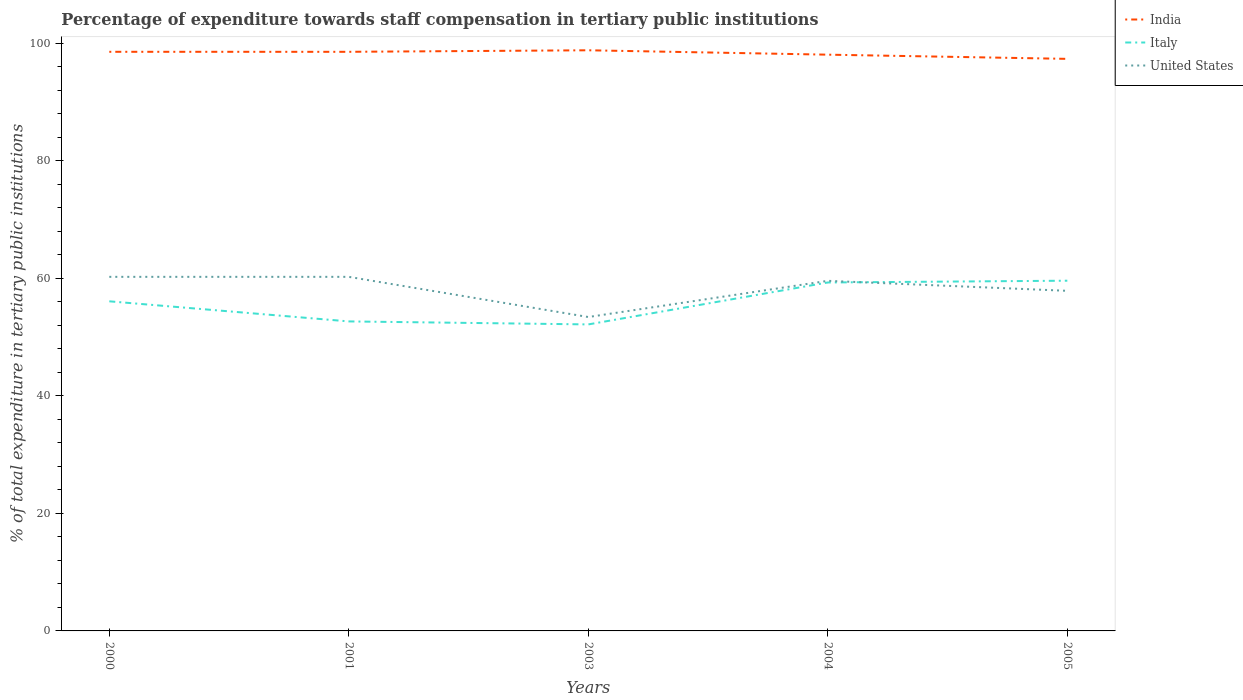How many different coloured lines are there?
Ensure brevity in your answer.  3. Across all years, what is the maximum percentage of expenditure towards staff compensation in Italy?
Keep it short and to the point. 52.15. In which year was the percentage of expenditure towards staff compensation in United States maximum?
Your answer should be very brief. 2003. What is the total percentage of expenditure towards staff compensation in India in the graph?
Ensure brevity in your answer.  1.2. What is the difference between the highest and the second highest percentage of expenditure towards staff compensation in United States?
Ensure brevity in your answer.  6.84. What is the difference between the highest and the lowest percentage of expenditure towards staff compensation in Italy?
Your response must be concise. 3. Is the percentage of expenditure towards staff compensation in United States strictly greater than the percentage of expenditure towards staff compensation in India over the years?
Your answer should be very brief. Yes. How many years are there in the graph?
Provide a succinct answer. 5. What is the difference between two consecutive major ticks on the Y-axis?
Your response must be concise. 20. Are the values on the major ticks of Y-axis written in scientific E-notation?
Offer a terse response. No. Where does the legend appear in the graph?
Make the answer very short. Top right. How many legend labels are there?
Offer a very short reply. 3. What is the title of the graph?
Provide a succinct answer. Percentage of expenditure towards staff compensation in tertiary public institutions. What is the label or title of the X-axis?
Provide a short and direct response. Years. What is the label or title of the Y-axis?
Provide a succinct answer. % of total expenditure in tertiary public institutions. What is the % of total expenditure in tertiary public institutions of India in 2000?
Give a very brief answer. 98.53. What is the % of total expenditure in tertiary public institutions in Italy in 2000?
Your response must be concise. 56.08. What is the % of total expenditure in tertiary public institutions of United States in 2000?
Make the answer very short. 60.24. What is the % of total expenditure in tertiary public institutions in India in 2001?
Make the answer very short. 98.53. What is the % of total expenditure in tertiary public institutions of Italy in 2001?
Provide a short and direct response. 52.66. What is the % of total expenditure in tertiary public institutions of United States in 2001?
Offer a very short reply. 60.24. What is the % of total expenditure in tertiary public institutions in India in 2003?
Provide a succinct answer. 98.79. What is the % of total expenditure in tertiary public institutions of Italy in 2003?
Your response must be concise. 52.15. What is the % of total expenditure in tertiary public institutions of United States in 2003?
Your response must be concise. 53.41. What is the % of total expenditure in tertiary public institutions of India in 2004?
Offer a terse response. 98.04. What is the % of total expenditure in tertiary public institutions of Italy in 2004?
Make the answer very short. 59.28. What is the % of total expenditure in tertiary public institutions in United States in 2004?
Give a very brief answer. 59.56. What is the % of total expenditure in tertiary public institutions in India in 2005?
Make the answer very short. 97.33. What is the % of total expenditure in tertiary public institutions of Italy in 2005?
Offer a terse response. 59.59. What is the % of total expenditure in tertiary public institutions of United States in 2005?
Give a very brief answer. 57.86. Across all years, what is the maximum % of total expenditure in tertiary public institutions in India?
Your response must be concise. 98.79. Across all years, what is the maximum % of total expenditure in tertiary public institutions of Italy?
Provide a short and direct response. 59.59. Across all years, what is the maximum % of total expenditure in tertiary public institutions in United States?
Provide a succinct answer. 60.24. Across all years, what is the minimum % of total expenditure in tertiary public institutions of India?
Your response must be concise. 97.33. Across all years, what is the minimum % of total expenditure in tertiary public institutions in Italy?
Offer a very short reply. 52.15. Across all years, what is the minimum % of total expenditure in tertiary public institutions in United States?
Make the answer very short. 53.41. What is the total % of total expenditure in tertiary public institutions in India in the graph?
Offer a terse response. 491.22. What is the total % of total expenditure in tertiary public institutions in Italy in the graph?
Provide a succinct answer. 279.76. What is the total % of total expenditure in tertiary public institutions of United States in the graph?
Your response must be concise. 291.32. What is the difference between the % of total expenditure in tertiary public institutions in India in 2000 and that in 2001?
Offer a very short reply. 0. What is the difference between the % of total expenditure in tertiary public institutions of Italy in 2000 and that in 2001?
Your answer should be compact. 3.42. What is the difference between the % of total expenditure in tertiary public institutions in United States in 2000 and that in 2001?
Provide a short and direct response. 0. What is the difference between the % of total expenditure in tertiary public institutions of India in 2000 and that in 2003?
Provide a short and direct response. -0.26. What is the difference between the % of total expenditure in tertiary public institutions of Italy in 2000 and that in 2003?
Ensure brevity in your answer.  3.93. What is the difference between the % of total expenditure in tertiary public institutions of United States in 2000 and that in 2003?
Make the answer very short. 6.84. What is the difference between the % of total expenditure in tertiary public institutions in India in 2000 and that in 2004?
Provide a succinct answer. 0.49. What is the difference between the % of total expenditure in tertiary public institutions of Italy in 2000 and that in 2004?
Your answer should be compact. -3.2. What is the difference between the % of total expenditure in tertiary public institutions in United States in 2000 and that in 2004?
Offer a terse response. 0.68. What is the difference between the % of total expenditure in tertiary public institutions in India in 2000 and that in 2005?
Your response must be concise. 1.2. What is the difference between the % of total expenditure in tertiary public institutions of Italy in 2000 and that in 2005?
Provide a succinct answer. -3.51. What is the difference between the % of total expenditure in tertiary public institutions in United States in 2000 and that in 2005?
Make the answer very short. 2.38. What is the difference between the % of total expenditure in tertiary public institutions of India in 2001 and that in 2003?
Your answer should be compact. -0.26. What is the difference between the % of total expenditure in tertiary public institutions of Italy in 2001 and that in 2003?
Keep it short and to the point. 0.51. What is the difference between the % of total expenditure in tertiary public institutions of United States in 2001 and that in 2003?
Keep it short and to the point. 6.84. What is the difference between the % of total expenditure in tertiary public institutions of India in 2001 and that in 2004?
Offer a terse response. 0.49. What is the difference between the % of total expenditure in tertiary public institutions in Italy in 2001 and that in 2004?
Your response must be concise. -6.62. What is the difference between the % of total expenditure in tertiary public institutions in United States in 2001 and that in 2004?
Your response must be concise. 0.68. What is the difference between the % of total expenditure in tertiary public institutions in India in 2001 and that in 2005?
Keep it short and to the point. 1.2. What is the difference between the % of total expenditure in tertiary public institutions in Italy in 2001 and that in 2005?
Give a very brief answer. -6.93. What is the difference between the % of total expenditure in tertiary public institutions of United States in 2001 and that in 2005?
Make the answer very short. 2.38. What is the difference between the % of total expenditure in tertiary public institutions of India in 2003 and that in 2004?
Provide a short and direct response. 0.75. What is the difference between the % of total expenditure in tertiary public institutions of Italy in 2003 and that in 2004?
Provide a short and direct response. -7.13. What is the difference between the % of total expenditure in tertiary public institutions of United States in 2003 and that in 2004?
Keep it short and to the point. -6.16. What is the difference between the % of total expenditure in tertiary public institutions in India in 2003 and that in 2005?
Your answer should be very brief. 1.46. What is the difference between the % of total expenditure in tertiary public institutions in Italy in 2003 and that in 2005?
Your answer should be very brief. -7.44. What is the difference between the % of total expenditure in tertiary public institutions of United States in 2003 and that in 2005?
Provide a short and direct response. -4.46. What is the difference between the % of total expenditure in tertiary public institutions of India in 2004 and that in 2005?
Provide a succinct answer. 0.71. What is the difference between the % of total expenditure in tertiary public institutions of Italy in 2004 and that in 2005?
Offer a very short reply. -0.3. What is the difference between the % of total expenditure in tertiary public institutions of United States in 2004 and that in 2005?
Make the answer very short. 1.7. What is the difference between the % of total expenditure in tertiary public institutions in India in 2000 and the % of total expenditure in tertiary public institutions in Italy in 2001?
Your response must be concise. 45.87. What is the difference between the % of total expenditure in tertiary public institutions in India in 2000 and the % of total expenditure in tertiary public institutions in United States in 2001?
Provide a succinct answer. 38.29. What is the difference between the % of total expenditure in tertiary public institutions of Italy in 2000 and the % of total expenditure in tertiary public institutions of United States in 2001?
Your answer should be compact. -4.16. What is the difference between the % of total expenditure in tertiary public institutions in India in 2000 and the % of total expenditure in tertiary public institutions in Italy in 2003?
Your answer should be very brief. 46.38. What is the difference between the % of total expenditure in tertiary public institutions in India in 2000 and the % of total expenditure in tertiary public institutions in United States in 2003?
Offer a very short reply. 45.12. What is the difference between the % of total expenditure in tertiary public institutions in Italy in 2000 and the % of total expenditure in tertiary public institutions in United States in 2003?
Keep it short and to the point. 2.67. What is the difference between the % of total expenditure in tertiary public institutions in India in 2000 and the % of total expenditure in tertiary public institutions in Italy in 2004?
Make the answer very short. 39.25. What is the difference between the % of total expenditure in tertiary public institutions in India in 2000 and the % of total expenditure in tertiary public institutions in United States in 2004?
Give a very brief answer. 38.97. What is the difference between the % of total expenditure in tertiary public institutions of Italy in 2000 and the % of total expenditure in tertiary public institutions of United States in 2004?
Make the answer very short. -3.48. What is the difference between the % of total expenditure in tertiary public institutions in India in 2000 and the % of total expenditure in tertiary public institutions in Italy in 2005?
Offer a very short reply. 38.94. What is the difference between the % of total expenditure in tertiary public institutions of India in 2000 and the % of total expenditure in tertiary public institutions of United States in 2005?
Keep it short and to the point. 40.67. What is the difference between the % of total expenditure in tertiary public institutions in Italy in 2000 and the % of total expenditure in tertiary public institutions in United States in 2005?
Offer a very short reply. -1.78. What is the difference between the % of total expenditure in tertiary public institutions in India in 2001 and the % of total expenditure in tertiary public institutions in Italy in 2003?
Your answer should be compact. 46.38. What is the difference between the % of total expenditure in tertiary public institutions in India in 2001 and the % of total expenditure in tertiary public institutions in United States in 2003?
Provide a short and direct response. 45.12. What is the difference between the % of total expenditure in tertiary public institutions of Italy in 2001 and the % of total expenditure in tertiary public institutions of United States in 2003?
Give a very brief answer. -0.75. What is the difference between the % of total expenditure in tertiary public institutions of India in 2001 and the % of total expenditure in tertiary public institutions of Italy in 2004?
Offer a terse response. 39.25. What is the difference between the % of total expenditure in tertiary public institutions in India in 2001 and the % of total expenditure in tertiary public institutions in United States in 2004?
Your answer should be compact. 38.96. What is the difference between the % of total expenditure in tertiary public institutions in Italy in 2001 and the % of total expenditure in tertiary public institutions in United States in 2004?
Offer a terse response. -6.91. What is the difference between the % of total expenditure in tertiary public institutions in India in 2001 and the % of total expenditure in tertiary public institutions in Italy in 2005?
Ensure brevity in your answer.  38.94. What is the difference between the % of total expenditure in tertiary public institutions of India in 2001 and the % of total expenditure in tertiary public institutions of United States in 2005?
Provide a succinct answer. 40.67. What is the difference between the % of total expenditure in tertiary public institutions of Italy in 2001 and the % of total expenditure in tertiary public institutions of United States in 2005?
Your answer should be compact. -5.2. What is the difference between the % of total expenditure in tertiary public institutions of India in 2003 and the % of total expenditure in tertiary public institutions of Italy in 2004?
Give a very brief answer. 39.51. What is the difference between the % of total expenditure in tertiary public institutions of India in 2003 and the % of total expenditure in tertiary public institutions of United States in 2004?
Make the answer very short. 39.22. What is the difference between the % of total expenditure in tertiary public institutions in Italy in 2003 and the % of total expenditure in tertiary public institutions in United States in 2004?
Your answer should be compact. -7.42. What is the difference between the % of total expenditure in tertiary public institutions of India in 2003 and the % of total expenditure in tertiary public institutions of Italy in 2005?
Make the answer very short. 39.2. What is the difference between the % of total expenditure in tertiary public institutions in India in 2003 and the % of total expenditure in tertiary public institutions in United States in 2005?
Your response must be concise. 40.92. What is the difference between the % of total expenditure in tertiary public institutions in Italy in 2003 and the % of total expenditure in tertiary public institutions in United States in 2005?
Provide a short and direct response. -5.72. What is the difference between the % of total expenditure in tertiary public institutions in India in 2004 and the % of total expenditure in tertiary public institutions in Italy in 2005?
Provide a succinct answer. 38.46. What is the difference between the % of total expenditure in tertiary public institutions in India in 2004 and the % of total expenditure in tertiary public institutions in United States in 2005?
Your response must be concise. 40.18. What is the difference between the % of total expenditure in tertiary public institutions in Italy in 2004 and the % of total expenditure in tertiary public institutions in United States in 2005?
Your response must be concise. 1.42. What is the average % of total expenditure in tertiary public institutions of India per year?
Your answer should be very brief. 98.24. What is the average % of total expenditure in tertiary public institutions in Italy per year?
Ensure brevity in your answer.  55.95. What is the average % of total expenditure in tertiary public institutions in United States per year?
Provide a short and direct response. 58.26. In the year 2000, what is the difference between the % of total expenditure in tertiary public institutions in India and % of total expenditure in tertiary public institutions in Italy?
Offer a very short reply. 42.45. In the year 2000, what is the difference between the % of total expenditure in tertiary public institutions in India and % of total expenditure in tertiary public institutions in United States?
Your answer should be compact. 38.29. In the year 2000, what is the difference between the % of total expenditure in tertiary public institutions of Italy and % of total expenditure in tertiary public institutions of United States?
Your answer should be compact. -4.16. In the year 2001, what is the difference between the % of total expenditure in tertiary public institutions of India and % of total expenditure in tertiary public institutions of Italy?
Provide a short and direct response. 45.87. In the year 2001, what is the difference between the % of total expenditure in tertiary public institutions in India and % of total expenditure in tertiary public institutions in United States?
Keep it short and to the point. 38.29. In the year 2001, what is the difference between the % of total expenditure in tertiary public institutions in Italy and % of total expenditure in tertiary public institutions in United States?
Your response must be concise. -7.58. In the year 2003, what is the difference between the % of total expenditure in tertiary public institutions of India and % of total expenditure in tertiary public institutions of Italy?
Keep it short and to the point. 46.64. In the year 2003, what is the difference between the % of total expenditure in tertiary public institutions of India and % of total expenditure in tertiary public institutions of United States?
Offer a terse response. 45.38. In the year 2003, what is the difference between the % of total expenditure in tertiary public institutions of Italy and % of total expenditure in tertiary public institutions of United States?
Your answer should be compact. -1.26. In the year 2004, what is the difference between the % of total expenditure in tertiary public institutions of India and % of total expenditure in tertiary public institutions of Italy?
Keep it short and to the point. 38.76. In the year 2004, what is the difference between the % of total expenditure in tertiary public institutions of India and % of total expenditure in tertiary public institutions of United States?
Your answer should be compact. 38.48. In the year 2004, what is the difference between the % of total expenditure in tertiary public institutions of Italy and % of total expenditure in tertiary public institutions of United States?
Make the answer very short. -0.28. In the year 2005, what is the difference between the % of total expenditure in tertiary public institutions in India and % of total expenditure in tertiary public institutions in Italy?
Keep it short and to the point. 37.74. In the year 2005, what is the difference between the % of total expenditure in tertiary public institutions of India and % of total expenditure in tertiary public institutions of United States?
Offer a very short reply. 39.47. In the year 2005, what is the difference between the % of total expenditure in tertiary public institutions in Italy and % of total expenditure in tertiary public institutions in United States?
Provide a succinct answer. 1.72. What is the ratio of the % of total expenditure in tertiary public institutions in India in 2000 to that in 2001?
Ensure brevity in your answer.  1. What is the ratio of the % of total expenditure in tertiary public institutions in Italy in 2000 to that in 2001?
Your answer should be compact. 1.06. What is the ratio of the % of total expenditure in tertiary public institutions of United States in 2000 to that in 2001?
Your answer should be compact. 1. What is the ratio of the % of total expenditure in tertiary public institutions in India in 2000 to that in 2003?
Your response must be concise. 1. What is the ratio of the % of total expenditure in tertiary public institutions in Italy in 2000 to that in 2003?
Make the answer very short. 1.08. What is the ratio of the % of total expenditure in tertiary public institutions of United States in 2000 to that in 2003?
Make the answer very short. 1.13. What is the ratio of the % of total expenditure in tertiary public institutions in India in 2000 to that in 2004?
Provide a succinct answer. 1. What is the ratio of the % of total expenditure in tertiary public institutions in Italy in 2000 to that in 2004?
Your answer should be very brief. 0.95. What is the ratio of the % of total expenditure in tertiary public institutions of United States in 2000 to that in 2004?
Provide a succinct answer. 1.01. What is the ratio of the % of total expenditure in tertiary public institutions in India in 2000 to that in 2005?
Offer a very short reply. 1.01. What is the ratio of the % of total expenditure in tertiary public institutions of Italy in 2000 to that in 2005?
Your response must be concise. 0.94. What is the ratio of the % of total expenditure in tertiary public institutions of United States in 2000 to that in 2005?
Your response must be concise. 1.04. What is the ratio of the % of total expenditure in tertiary public institutions in Italy in 2001 to that in 2003?
Your answer should be very brief. 1.01. What is the ratio of the % of total expenditure in tertiary public institutions in United States in 2001 to that in 2003?
Make the answer very short. 1.13. What is the ratio of the % of total expenditure in tertiary public institutions in India in 2001 to that in 2004?
Ensure brevity in your answer.  1. What is the ratio of the % of total expenditure in tertiary public institutions in Italy in 2001 to that in 2004?
Offer a terse response. 0.89. What is the ratio of the % of total expenditure in tertiary public institutions in United States in 2001 to that in 2004?
Ensure brevity in your answer.  1.01. What is the ratio of the % of total expenditure in tertiary public institutions of India in 2001 to that in 2005?
Your response must be concise. 1.01. What is the ratio of the % of total expenditure in tertiary public institutions of Italy in 2001 to that in 2005?
Your answer should be compact. 0.88. What is the ratio of the % of total expenditure in tertiary public institutions of United States in 2001 to that in 2005?
Your answer should be very brief. 1.04. What is the ratio of the % of total expenditure in tertiary public institutions in India in 2003 to that in 2004?
Your response must be concise. 1.01. What is the ratio of the % of total expenditure in tertiary public institutions in Italy in 2003 to that in 2004?
Offer a terse response. 0.88. What is the ratio of the % of total expenditure in tertiary public institutions of United States in 2003 to that in 2004?
Provide a short and direct response. 0.9. What is the ratio of the % of total expenditure in tertiary public institutions of Italy in 2003 to that in 2005?
Your answer should be very brief. 0.88. What is the ratio of the % of total expenditure in tertiary public institutions in United States in 2003 to that in 2005?
Provide a short and direct response. 0.92. What is the ratio of the % of total expenditure in tertiary public institutions of India in 2004 to that in 2005?
Keep it short and to the point. 1.01. What is the ratio of the % of total expenditure in tertiary public institutions in Italy in 2004 to that in 2005?
Keep it short and to the point. 0.99. What is the ratio of the % of total expenditure in tertiary public institutions of United States in 2004 to that in 2005?
Give a very brief answer. 1.03. What is the difference between the highest and the second highest % of total expenditure in tertiary public institutions in India?
Your response must be concise. 0.26. What is the difference between the highest and the second highest % of total expenditure in tertiary public institutions in Italy?
Make the answer very short. 0.3. What is the difference between the highest and the second highest % of total expenditure in tertiary public institutions of United States?
Your answer should be compact. 0. What is the difference between the highest and the lowest % of total expenditure in tertiary public institutions of India?
Your answer should be compact. 1.46. What is the difference between the highest and the lowest % of total expenditure in tertiary public institutions in Italy?
Ensure brevity in your answer.  7.44. What is the difference between the highest and the lowest % of total expenditure in tertiary public institutions of United States?
Keep it short and to the point. 6.84. 